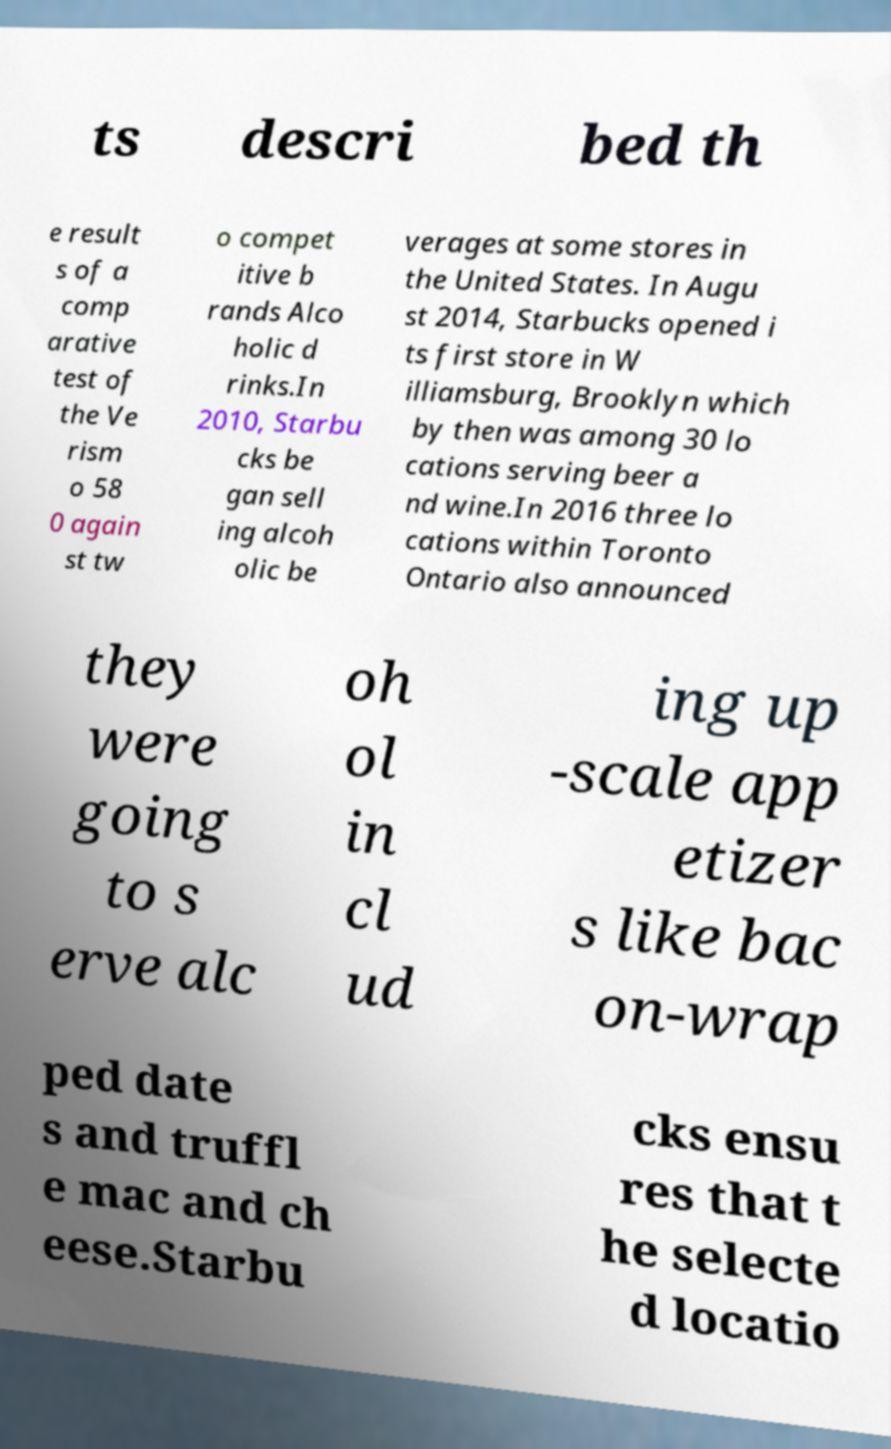There's text embedded in this image that I need extracted. Can you transcribe it verbatim? ts descri bed th e result s of a comp arative test of the Ve rism o 58 0 again st tw o compet itive b rands Alco holic d rinks.In 2010, Starbu cks be gan sell ing alcoh olic be verages at some stores in the United States. In Augu st 2014, Starbucks opened i ts first store in W illiamsburg, Brooklyn which by then was among 30 lo cations serving beer a nd wine.In 2016 three lo cations within Toronto Ontario also announced they were going to s erve alc oh ol in cl ud ing up -scale app etizer s like bac on-wrap ped date s and truffl e mac and ch eese.Starbu cks ensu res that t he selecte d locatio 